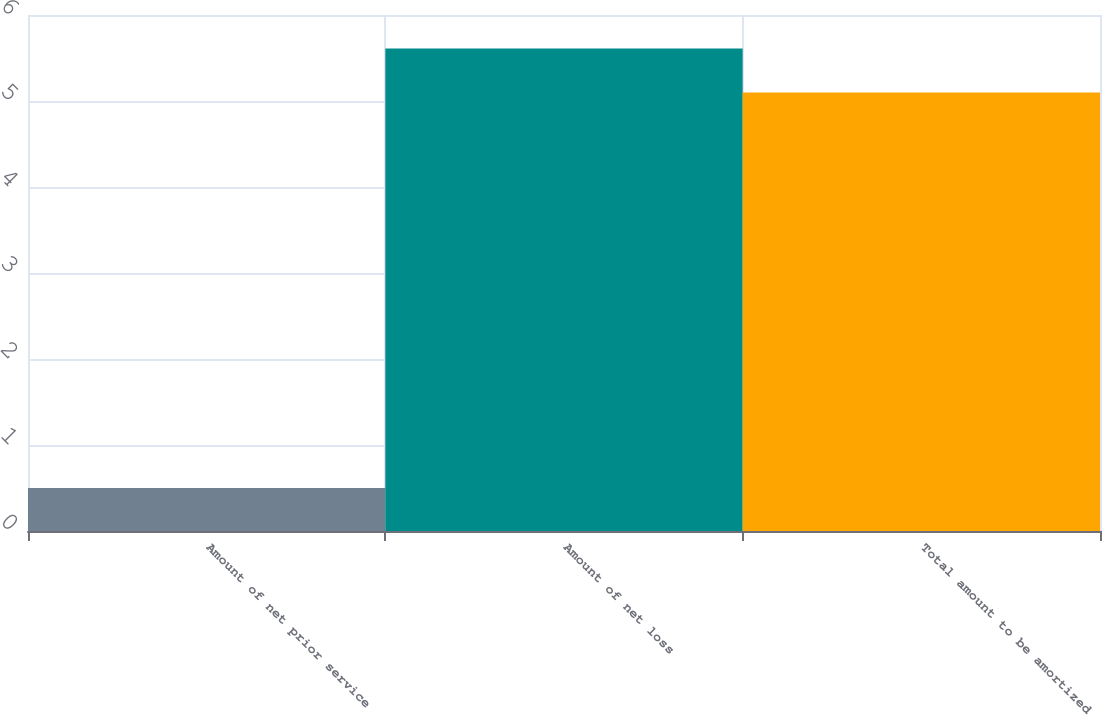<chart> <loc_0><loc_0><loc_500><loc_500><bar_chart><fcel>Amount of net prior service<fcel>Amount of net loss<fcel>Total amount to be amortized<nl><fcel>0.5<fcel>5.61<fcel>5.1<nl></chart> 